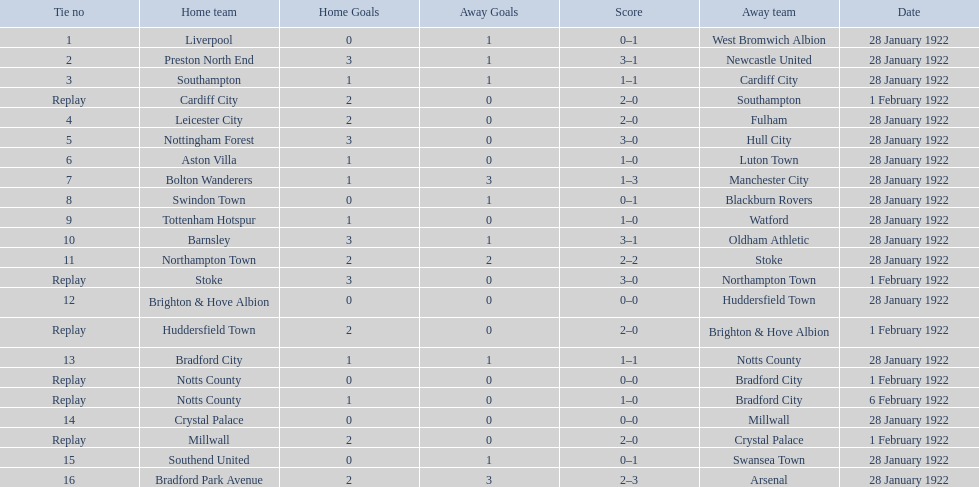What are all of the home teams? Liverpool, Preston North End, Southampton, Cardiff City, Leicester City, Nottingham Forest, Aston Villa, Bolton Wanderers, Swindon Town, Tottenham Hotspur, Barnsley, Northampton Town, Stoke, Brighton & Hove Albion, Huddersfield Town, Bradford City, Notts County, Notts County, Crystal Palace, Millwall, Southend United, Bradford Park Avenue. What were the scores? 0–1, 3–1, 1–1, 2–0, 2–0, 3–0, 1–0, 1–3, 0–1, 1–0, 3–1, 2–2, 3–0, 0–0, 2–0, 1–1, 0–0, 1–0, 0–0, 2–0, 0–1, 2–3. On which dates did they play? 28 January 1922, 28 January 1922, 28 January 1922, 1 February 1922, 28 January 1922, 28 January 1922, 28 January 1922, 28 January 1922, 28 January 1922, 28 January 1922, 28 January 1922, 28 January 1922, 1 February 1922, 28 January 1922, 1 February 1922, 28 January 1922, 1 February 1922, 6 February 1922, 28 January 1922, 1 February 1922, 28 January 1922, 28 January 1922. Which teams played on 28 january 1922? Liverpool, Preston North End, Southampton, Leicester City, Nottingham Forest, Aston Villa, Bolton Wanderers, Swindon Town, Tottenham Hotspur, Barnsley, Northampton Town, Brighton & Hove Albion, Bradford City, Crystal Palace, Southend United, Bradford Park Avenue. Of those, which scored the same as aston villa? Tottenham Hotspur. 